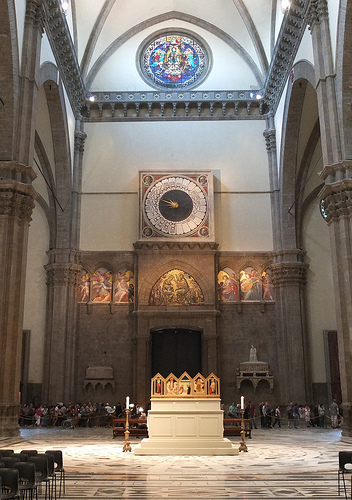If the cathedral suddenly transformed into a giant spaceship, what features would make it an effective interstellar vessel? If the cathedral transformed into a giant spaceship, it would retain its majestic stained glass windows, which would now function as solar panels harvesting energy from stars. The high arches and vaulted ceilings would create spacious chambers perfect for zero-gravity gyms and hydroponic gardens. The intricate carvings and statues would double as control panels and communication devices, blending art with advanced technology. The bell tower would act as the main navigation hub, directing the ship through the cosmos with precision. The spaceship’s exterior would be reinforced with an energy field, illuminated by the dazzling light of far-off galaxies. This combination of history and high-tech innovation would make the cathedral a remarkable and awe-inspiring vessel for interstellar travel. 